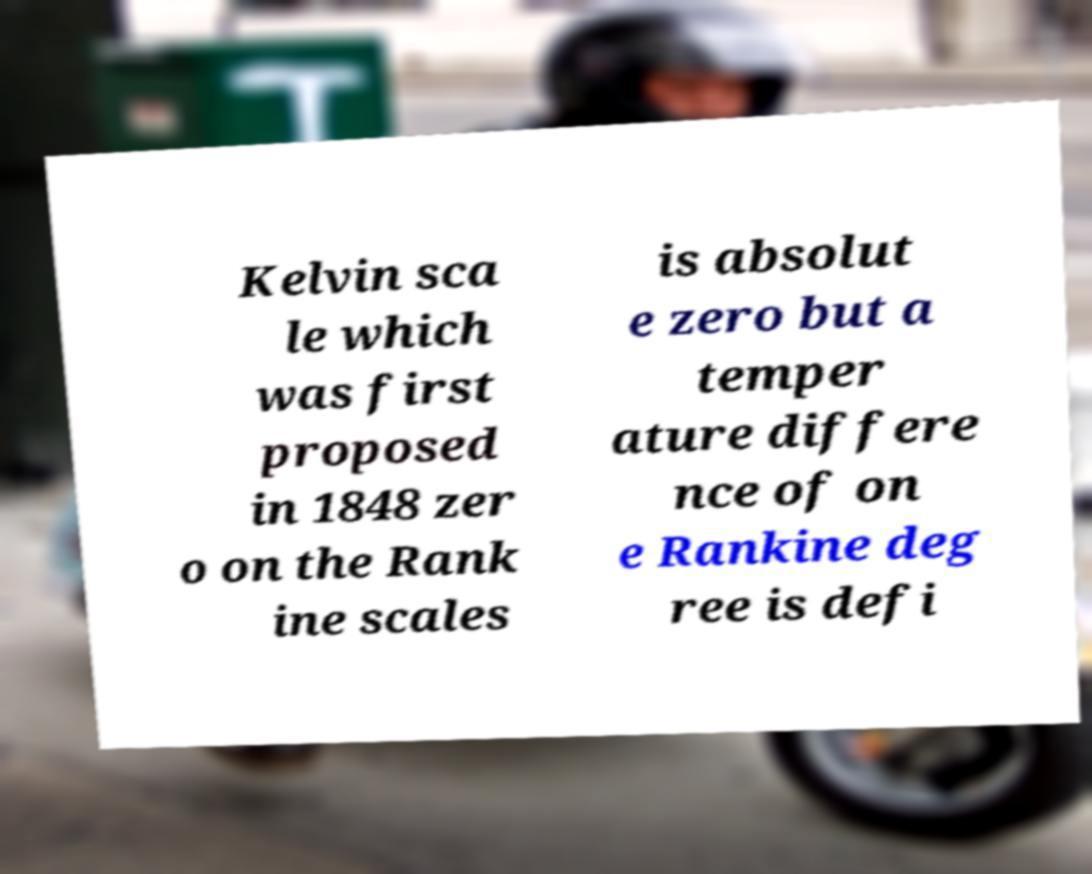What messages or text are displayed in this image? I need them in a readable, typed format. Kelvin sca le which was first proposed in 1848 zer o on the Rank ine scales is absolut e zero but a temper ature differe nce of on e Rankine deg ree is defi 